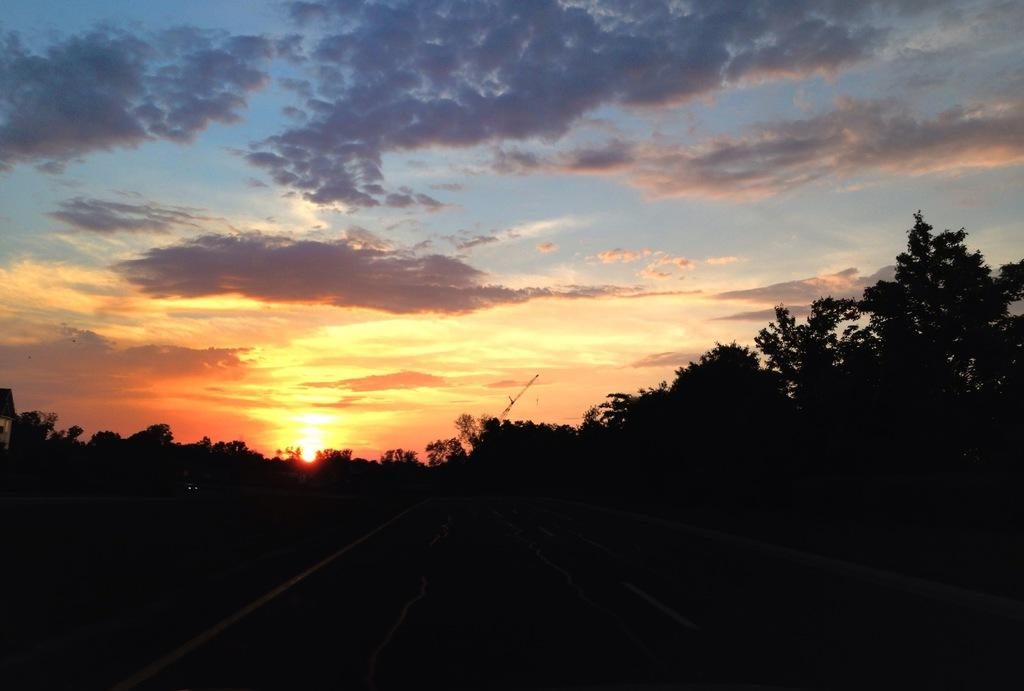What type of vegetation can be seen in the image? There are trees in the image. What is visible in the background of the image? The sky is visible in the background of the image. What colors can be observed in the sky? The sky is blue, white, and orange in color. What type of square object can be seen in the image? There is no square object present in the image; it features trees and a sky with blue, white, and orange colors. Can you tell me how many times the story is folded in the image? There is no story present in the image to be folded. 